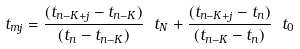<formula> <loc_0><loc_0><loc_500><loc_500>t _ { m j } = \frac { ( t _ { n - K + j } - t _ { n - K } ) } { ( t _ { n } - t _ { n - K } ) } \ t _ { N } + \frac { ( t _ { n - K + j } - t _ { n } ) } { ( t _ { n - K } - t _ { n } ) } \ t _ { 0 }</formula> 